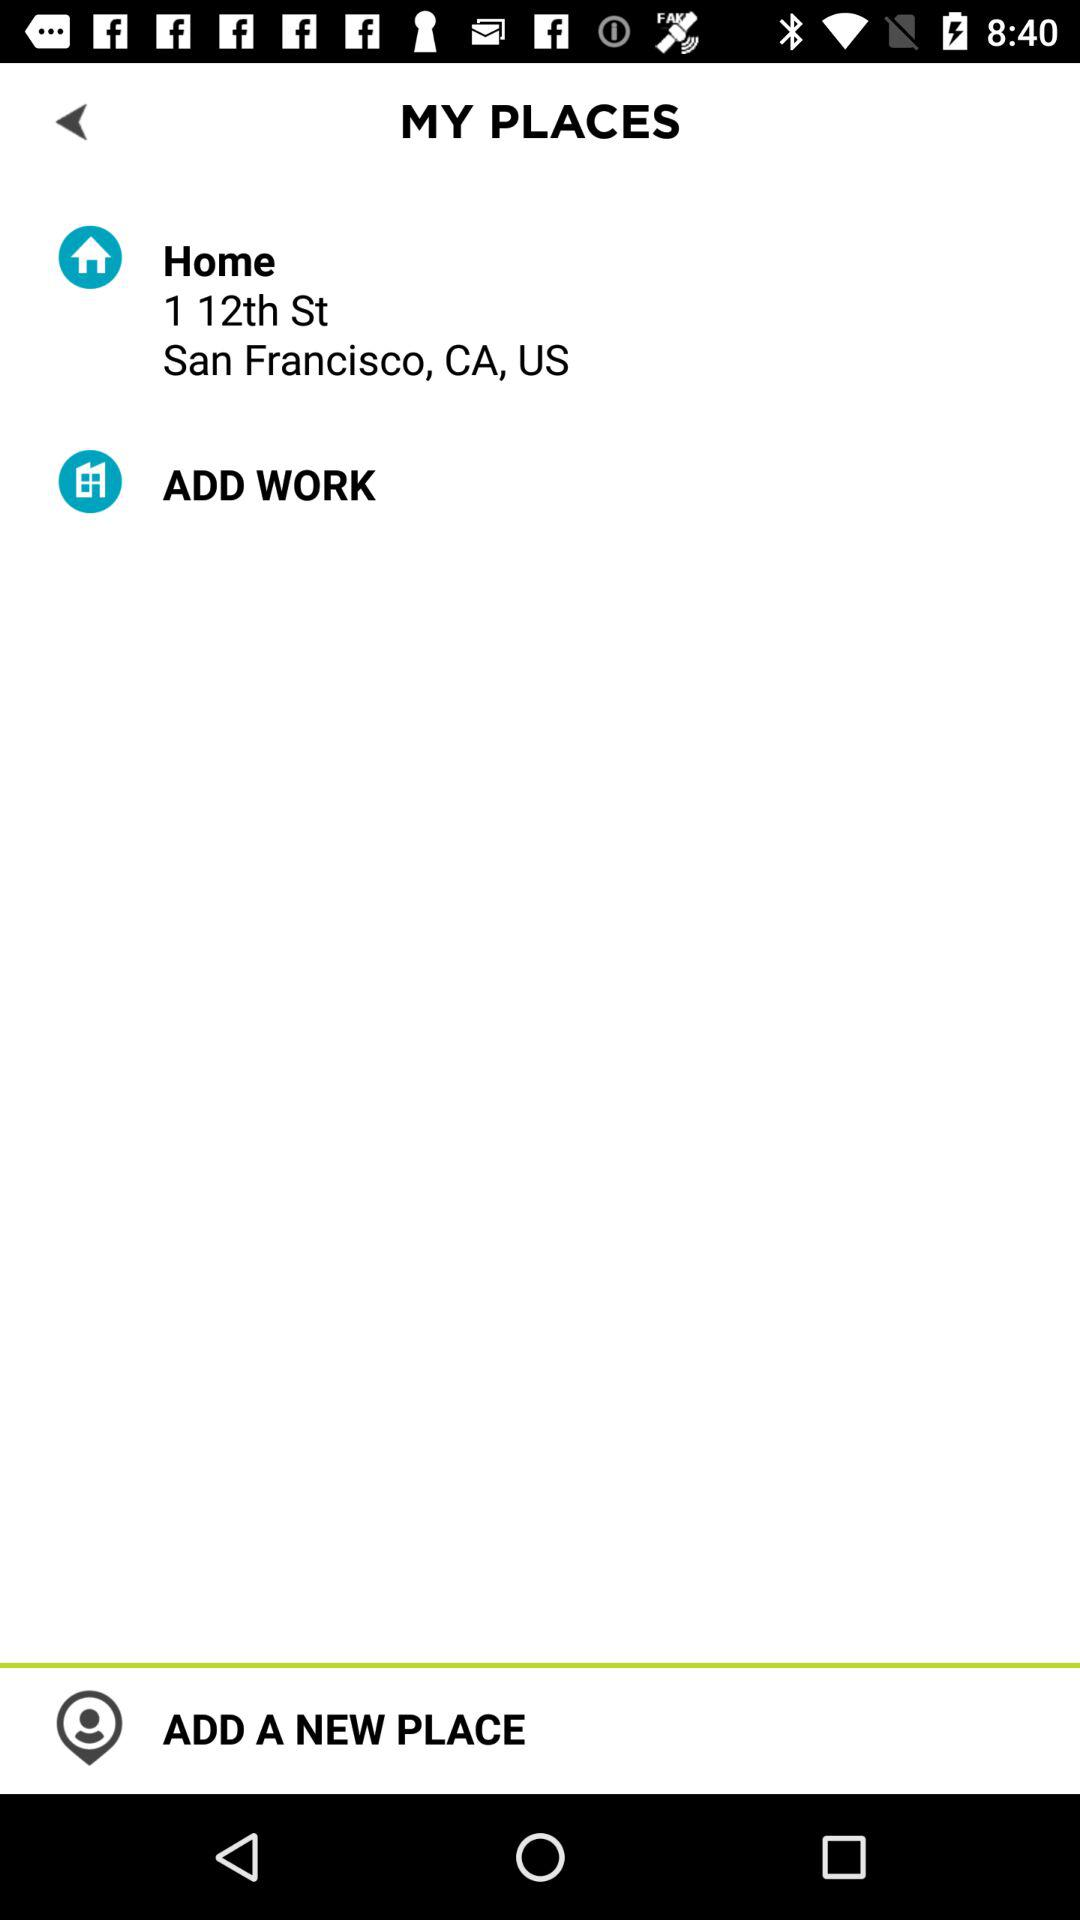What is the location of the home? The location of the home is 1 12th St, San Francisco, CA, USA. 